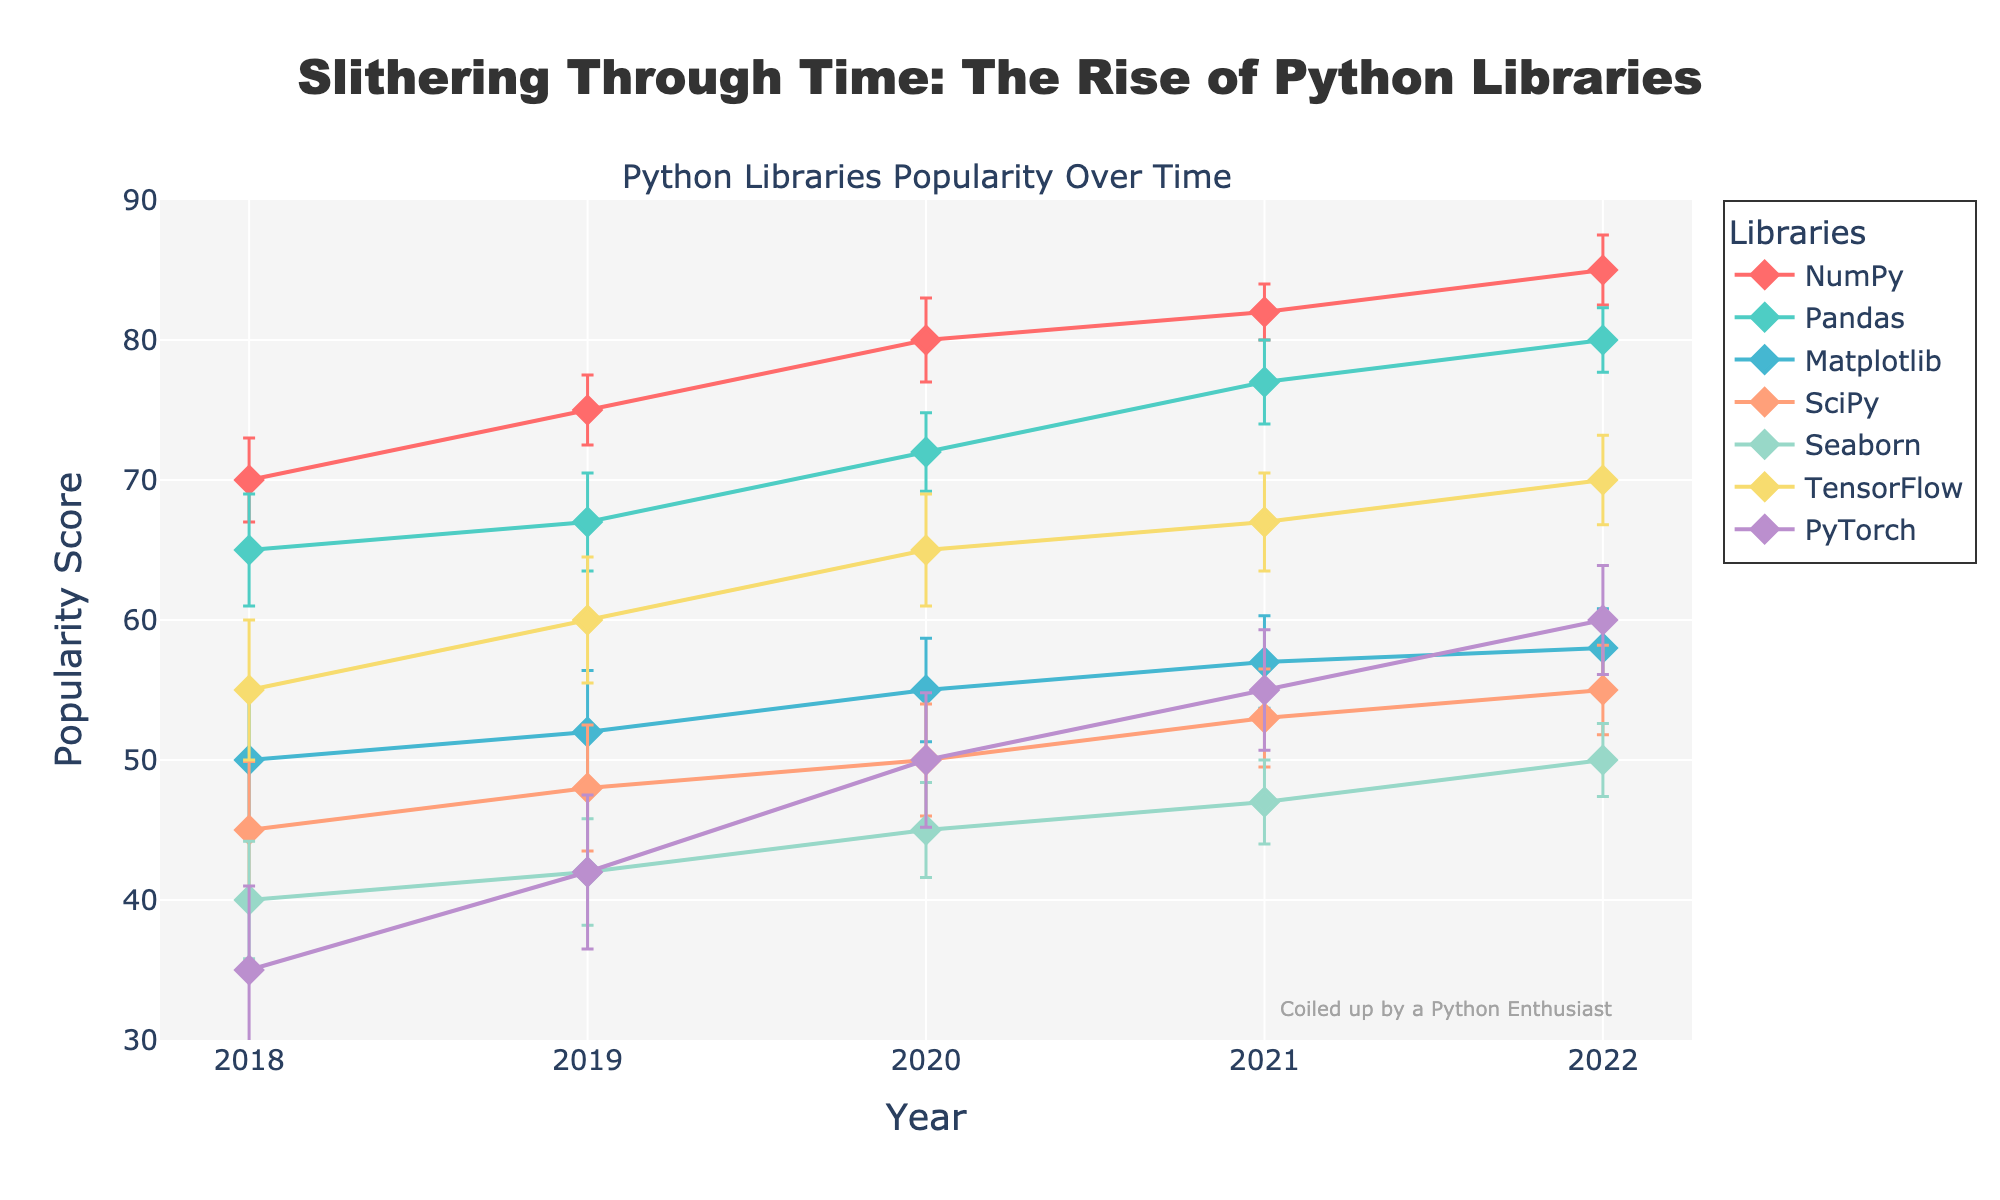What's the title of the plot? The plot title is displayed at the top center of the image, often in a larger font size than other text elements. It's the primary textual information that provides context about the plot.
Answer: Slithering Through Time: The Rise of Python Libraries Which library had the highest popularity in 2022? To answer this, check the 2022 data points for all the libraries and identify the maximum popularity value. Among the points, NumPy has the highest popularity.
Answer: NumPy What is the average popularity score for Pandas from 2018 to 2022? First, list the popularity scores for Pandas across the years: 65 (2018), 67 (2019), 72 (2020), 77 (2021), and 80 (2022). Then, calculate the average: (65 + 67 + 72 + 77 + 80) / 5 = 72.2
Answer: 72.2 Which library showed the largest increase in popularity from 2018 to 2022? For each library, subtract the 2018 popularity from the 2022 popularity. NumPy: 85-70=15, Pandas: 80-65=15, Matplotlib: 58-50=8, SciPy: 55-45=10, Seaborn: 50-40=10, TensorFlow: 70-55=15, PyTorch: 60-35=25. PyTorch has the largest increase.
Answer: PyTorch Which year's data point for NumPy has the smallest error bar? Examine NumPy's error bars across the years and compare their lengths. The smallest error bar occurs in 2021 with an error of 2.
Answer: 2021 Between TensorFlow and PyTorch, which library had a higher popularity in 2020, and by how much? Compare the popularity of TensorFlow (65) and PyTorch (50) in 2020. TensorFlow's popularity is higher. The difference is 65 - 50 = 15.
Answer: TensorFlow by 15 What is the range of popularity scores for Matplotlib from 2018 to 2022? Identify the minimum and maximum popularity scores for Matplotlib: the minimum is 50 (2018) and the maximum is 58 (2022). The range is 58 - 50 = 8.
Answer: 8 Which library has the most consistently rising popularity trend over the given years? Examine the trends of each library's popularity. A consistent rise means that each year's popularity is higher than the previous year's. TensorFlow has a steady, non-decreasing trend each year from 55 in 2018 to 70 in 2022.
Answer: TensorFlow In which year did Seaborn see the highest increase in popularity compared to the previous year? Calculate the year-over-year increase for Seaborn: 2019 (42-40=2), 2020 (45-42=3), 2021 (47-45=2), 2022 (50-47=3). Both 2020 and 2022 have the highest increase of 3.
Answer: 2020 and 2022 